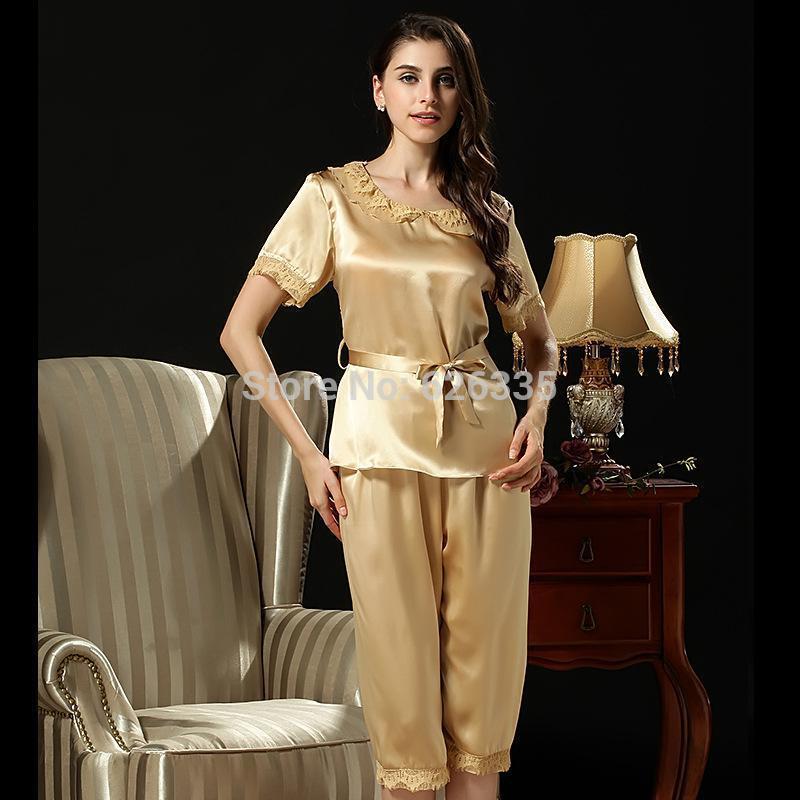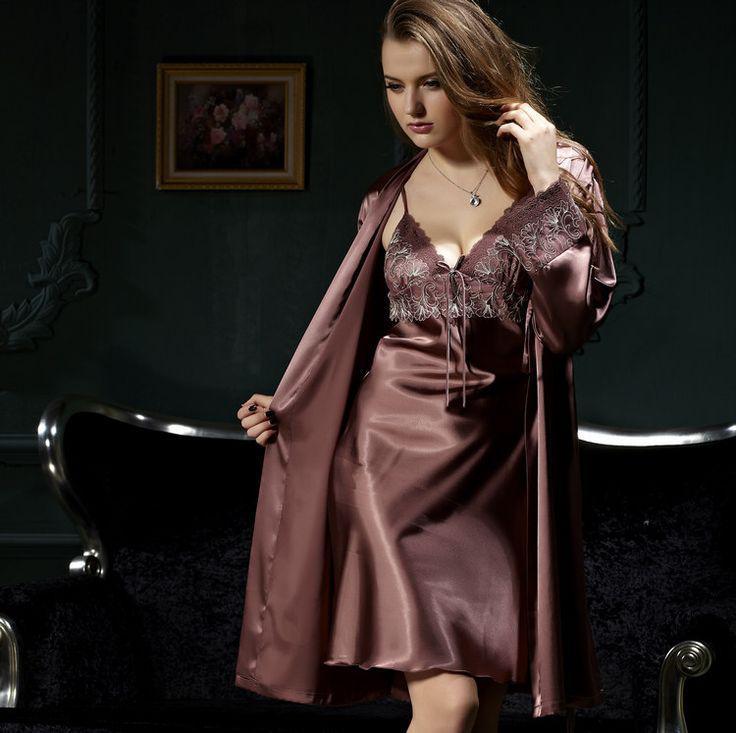The first image is the image on the left, the second image is the image on the right. Assess this claim about the two images: "Pajama pants in one image are knee length with lace edging, topped with a pajama shirt with tie belt at the waist.". Correct or not? Answer yes or no. Yes. The first image is the image on the left, the second image is the image on the right. Evaluate the accuracy of this statement regarding the images: "The model on the left wears matching short-sleeve pajama top and capri-length bottoms, and the model on the right wears a robe over a spaghetti-strap gown.". Is it true? Answer yes or no. Yes. 